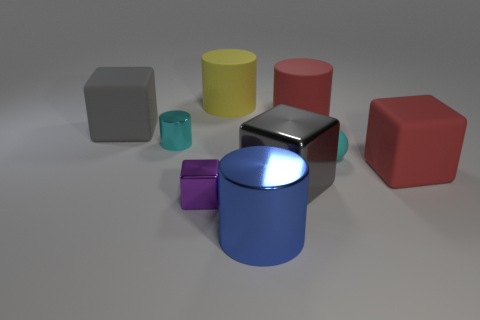What is the big blue object made of?
Ensure brevity in your answer.  Metal. The large blue thing is what shape?
Ensure brevity in your answer.  Cylinder. What number of metallic blocks have the same color as the tiny sphere?
Provide a short and direct response. 0. What is the material of the gray thing behind the rubber cube that is in front of the cyan object to the right of the red matte cylinder?
Ensure brevity in your answer.  Rubber. What number of yellow objects are matte cylinders or tiny spheres?
Give a very brief answer. 1. What size is the ball that is to the left of the red object that is in front of the large red object that is behind the tiny cyan rubber sphere?
Your answer should be compact. Small. The purple metal thing that is the same shape as the gray matte thing is what size?
Make the answer very short. Small. How many tiny objects are either yellow matte things or blue rubber spheres?
Your response must be concise. 0. Is the material of the object that is right of the tiny ball the same as the large gray thing to the right of the big gray matte cube?
Keep it short and to the point. No. There is a cyan object that is in front of the cyan shiny thing; what material is it?
Ensure brevity in your answer.  Rubber. 